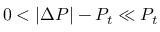<formula> <loc_0><loc_0><loc_500><loc_500>0 < | \Delta P | - P _ { t } \ll P _ { t }</formula> 